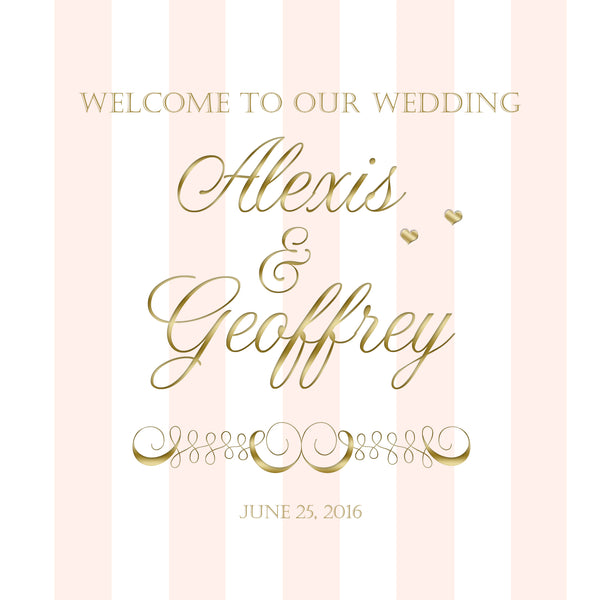Based on the design elements and color scheme used in this wedding invitation, what season of the year might the wedding be taking place, and what time of day does it suggest for the ceremony? The wedding is likely taking place in the summer, as indicated by the date "June 25, 2016." The use of elegant gold text and accents combined with a soft pink background suggests a warm and sophisticated summer wedding theme. Gold is often associated with evening events due to its warm, ambient glow, which implies that the wedding ceremony or reception might be held in the evening. However, the color scheme of gold and pink can be suitable for both daytime and evening events, making it versatile for various times of the day. 